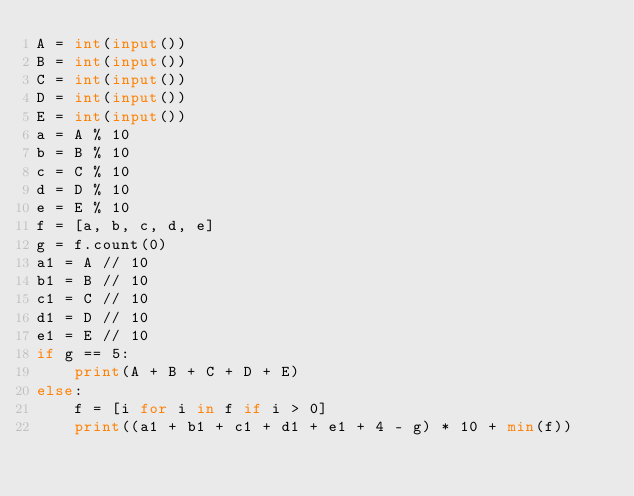<code> <loc_0><loc_0><loc_500><loc_500><_Python_>A = int(input())
B = int(input())
C = int(input())
D = int(input())
E = int(input())
a = A % 10
b = B % 10
c = C % 10
d = D % 10
e = E % 10
f = [a, b, c, d, e]
g = f.count(0)
a1 = A // 10
b1 = B // 10
c1 = C // 10
d1 = D // 10
e1 = E // 10
if g == 5:
    print(A + B + C + D + E)
else:
    f = [i for i in f if i > 0]
    print((a1 + b1 + c1 + d1 + e1 + 4 - g) * 10 + min(f))</code> 